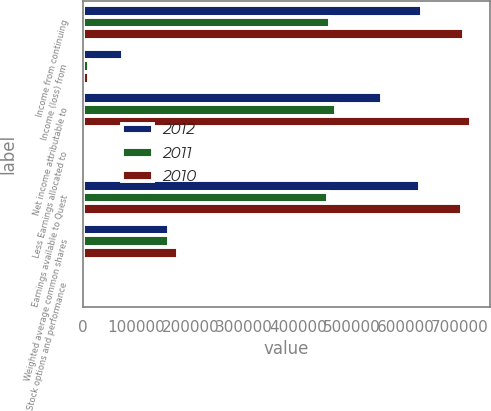Convert chart to OTSL. <chart><loc_0><loc_0><loc_500><loc_500><stacked_bar_chart><ecel><fcel>Income from continuing<fcel>Income (loss) from<fcel>Net income attributable to<fcel>Less Earnings allocated to<fcel>Earnings available to Quest<fcel>Weighted average common shares<fcel>Stock options and performance<nl><fcel>2012<fcel>630085<fcel>74364<fcel>555721<fcel>2506<fcel>627579<fcel>160065<fcel>1493<nl><fcel>2011<fcel>459009<fcel>11558<fcel>470567<fcel>2907<fcel>456102<fcel>160172<fcel>1500<nl><fcel>2010<fcel>708734<fcel>12160<fcel>720894<fcel>3292<fcel>705442<fcel>177320<fcel>1636<nl></chart> 